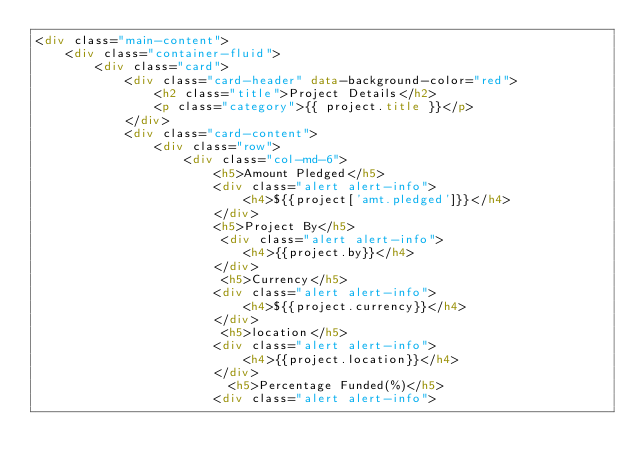Convert code to text. <code><loc_0><loc_0><loc_500><loc_500><_HTML_><div class="main-content">
    <div class="container-fluid">
        <div class="card">
            <div class="card-header" data-background-color="red">
                <h2 class="title">Project Details</h2>
                <p class="category">{{ project.title }}</p>
            </div>
            <div class="card-content">
                <div class="row">
                    <div class="col-md-6">
                        <h5>Amount Pledged</h5>
                        <div class="alert alert-info">
                            <h4>${{project['amt.pledged']}}</h4>
                        </div>
                        <h5>Project By</h5>
                         <div class="alert alert-info">
                            <h4>{{project.by}}</h4>
                        </div>
                         <h5>Currency</h5>
                        <div class="alert alert-info">
                            <h4>${{project.currency}}</h4>
                        </div>
                         <h5>location</h5>
                        <div class="alert alert-info">
                            <h4>{{project.location}}</h4>
                        </div>
                          <h5>Percentage Funded(%)</h5>
                        <div class="alert alert-info"></code> 